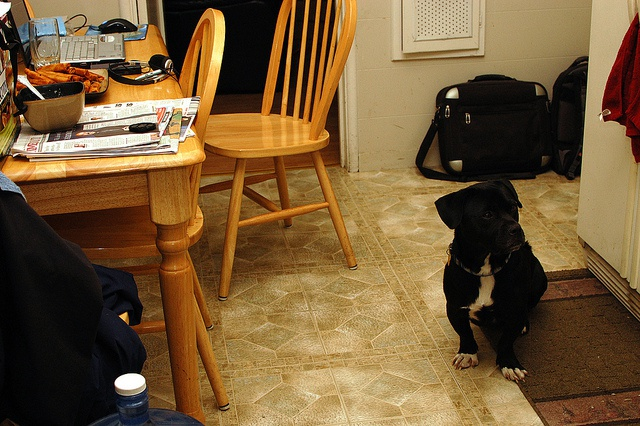Describe the objects in this image and their specific colors. I can see chair in black, olive, maroon, and orange tones, dining table in black, brown, maroon, and ivory tones, backpack in black, maroon, darkgray, and gray tones, dog in black, olive, and maroon tones, and handbag in black, olive, and maroon tones in this image. 